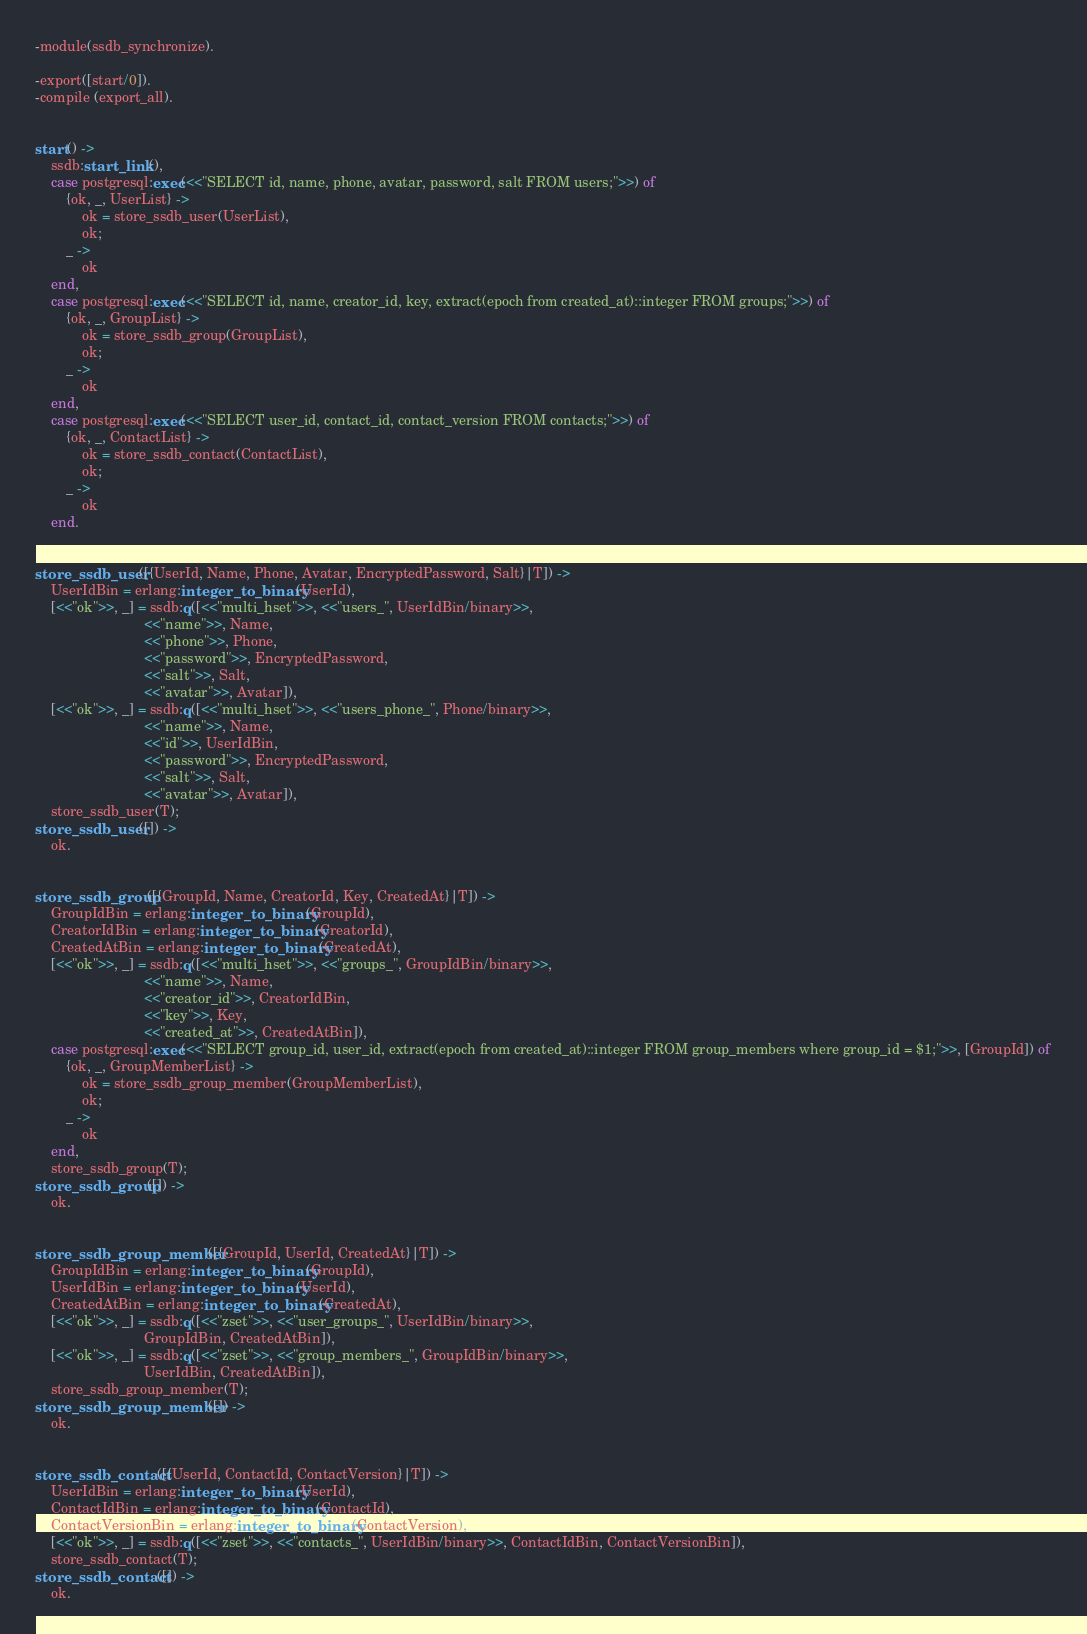Convert code to text. <code><loc_0><loc_0><loc_500><loc_500><_Erlang_>-module(ssdb_synchronize).

-export([start/0]).
-compile (export_all).


start() ->
    ssdb:start_link(),
    case postgresql:exec(<<"SELECT id, name, phone, avatar, password, salt FROM users;">>) of
        {ok, _, UserList} ->
            ok = store_ssdb_user(UserList),
            ok;
        _ ->
            ok
    end,
    case postgresql:exec(<<"SELECT id, name, creator_id, key, extract(epoch from created_at)::integer FROM groups;">>) of
        {ok, _, GroupList} ->
            ok = store_ssdb_group(GroupList),
            ok;
        _ ->
            ok
    end,
    case postgresql:exec(<<"SELECT user_id, contact_id, contact_version FROM contacts;">>) of
        {ok, _, ContactList} ->
            ok = store_ssdb_contact(ContactList),
            ok;
        _ ->
            ok
    end.


store_ssdb_user([{UserId, Name, Phone, Avatar, EncryptedPassword, Salt}|T]) ->
    UserIdBin = erlang:integer_to_binary(UserId),
    [<<"ok">>, _] = ssdb:q([<<"multi_hset">>, <<"users_", UserIdBin/binary>>,
                            <<"name">>, Name,
                            <<"phone">>, Phone,
                            <<"password">>, EncryptedPassword,
                            <<"salt">>, Salt,
                            <<"avatar">>, Avatar]),
    [<<"ok">>, _] = ssdb:q([<<"multi_hset">>, <<"users_phone_", Phone/binary>>,
                            <<"name">>, Name,
                            <<"id">>, UserIdBin,
                            <<"password">>, EncryptedPassword,
                            <<"salt">>, Salt,
                            <<"avatar">>, Avatar]),
    store_ssdb_user(T);
store_ssdb_user([]) ->
    ok.


store_ssdb_group([{GroupId, Name, CreatorId, Key, CreatedAt}|T]) ->
    GroupIdBin = erlang:integer_to_binary(GroupId),
    CreatorIdBin = erlang:integer_to_binary(CreatorId),
    CreatedAtBin = erlang:integer_to_binary(CreatedAt),
    [<<"ok">>, _] = ssdb:q([<<"multi_hset">>, <<"groups_", GroupIdBin/binary>>,
                            <<"name">>, Name,
                            <<"creator_id">>, CreatorIdBin,
                            <<"key">>, Key,
                            <<"created_at">>, CreatedAtBin]),
    case postgresql:exec(<<"SELECT group_id, user_id, extract(epoch from created_at)::integer FROM group_members where group_id = $1;">>, [GroupId]) of
        {ok, _, GroupMemberList} ->
            ok = store_ssdb_group_member(GroupMemberList),
            ok;
        _ ->
            ok
    end,
    store_ssdb_group(T);
store_ssdb_group([]) ->
    ok.


store_ssdb_group_member([{GroupId, UserId, CreatedAt}|T]) ->
    GroupIdBin = erlang:integer_to_binary(GroupId),
    UserIdBin = erlang:integer_to_binary(UserId),
    CreatedAtBin = erlang:integer_to_binary(CreatedAt),
    [<<"ok">>, _] = ssdb:q([<<"zset">>, <<"user_groups_", UserIdBin/binary>>,
                            GroupIdBin, CreatedAtBin]),
    [<<"ok">>, _] = ssdb:q([<<"zset">>, <<"group_members_", GroupIdBin/binary>>,
                            UserIdBin, CreatedAtBin]),
    store_ssdb_group_member(T);
store_ssdb_group_member([]) ->
    ok.


store_ssdb_contact([{UserId, ContactId, ContactVersion}|T]) ->
    UserIdBin = erlang:integer_to_binary(UserId),
    ContactIdBin = erlang:integer_to_binary(ContactId),
    ContactVersionBin = erlang:integer_to_binary(ContactVersion),
    [<<"ok">>, _] = ssdb:q([<<"zset">>, <<"contacts_", UserIdBin/binary>>, ContactIdBin, ContactVersionBin]),
    store_ssdb_contact(T);
store_ssdb_contact([]) ->
    ok.</code> 